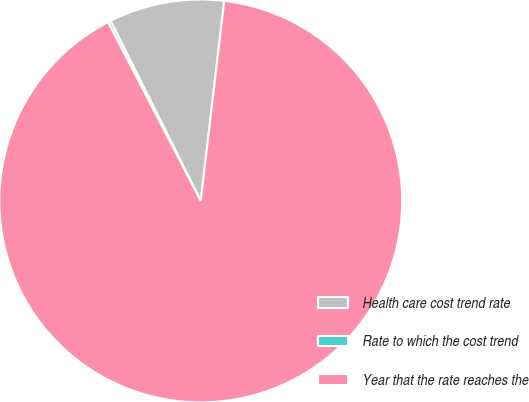<chart> <loc_0><loc_0><loc_500><loc_500><pie_chart><fcel>Health care cost trend rate<fcel>Rate to which the cost trend<fcel>Year that the rate reaches the<nl><fcel>9.25%<fcel>0.22%<fcel>90.52%<nl></chart> 